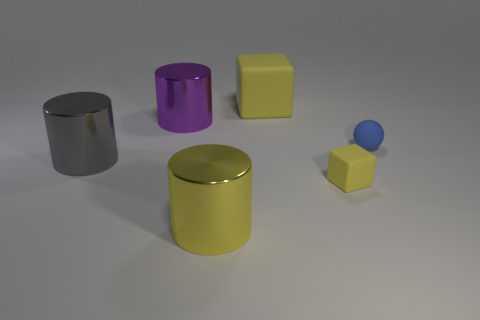Subtract all large gray cylinders. How many cylinders are left? 2 Subtract all purple cylinders. How many cylinders are left? 2 Add 3 tiny cubes. How many objects exist? 9 Subtract 1 cylinders. How many cylinders are left? 2 Subtract all spheres. How many objects are left? 5 Subtract all cyan cylinders. Subtract all blue spheres. How many cylinders are left? 3 Subtract all red spheres. How many yellow cylinders are left? 1 Subtract all big purple matte blocks. Subtract all big yellow blocks. How many objects are left? 5 Add 4 small blue things. How many small blue things are left? 5 Add 3 blue cubes. How many blue cubes exist? 3 